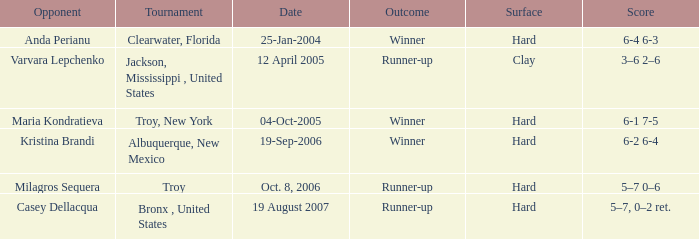What is the score of the game that was played against Maria Kondratieva? 6-1 7-5. 